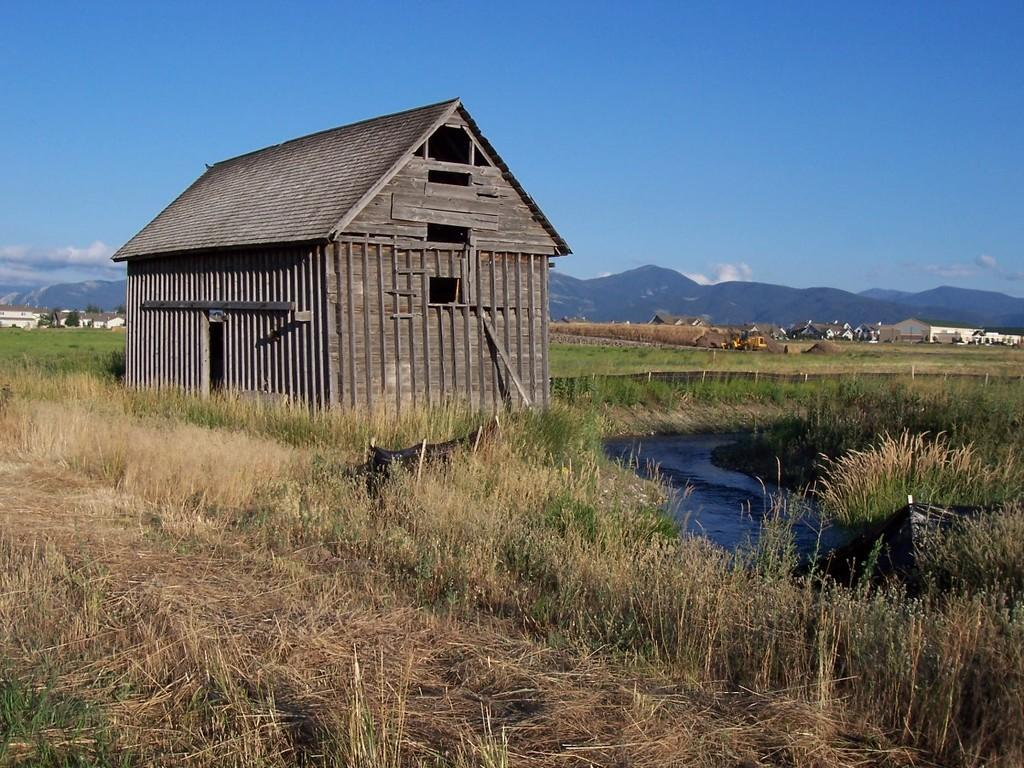What type of structure is visible in the image? There is a hut in the image. What natural elements can be seen in the image? There are trees, plants, and grass in the image. Are there any other buildings in the image? Yes, there are other houses in the image. How many pairs of shoes are visible in the image? There are no shoes visible in the image. What type of error can be seen in the image? There is no error present in the image. 